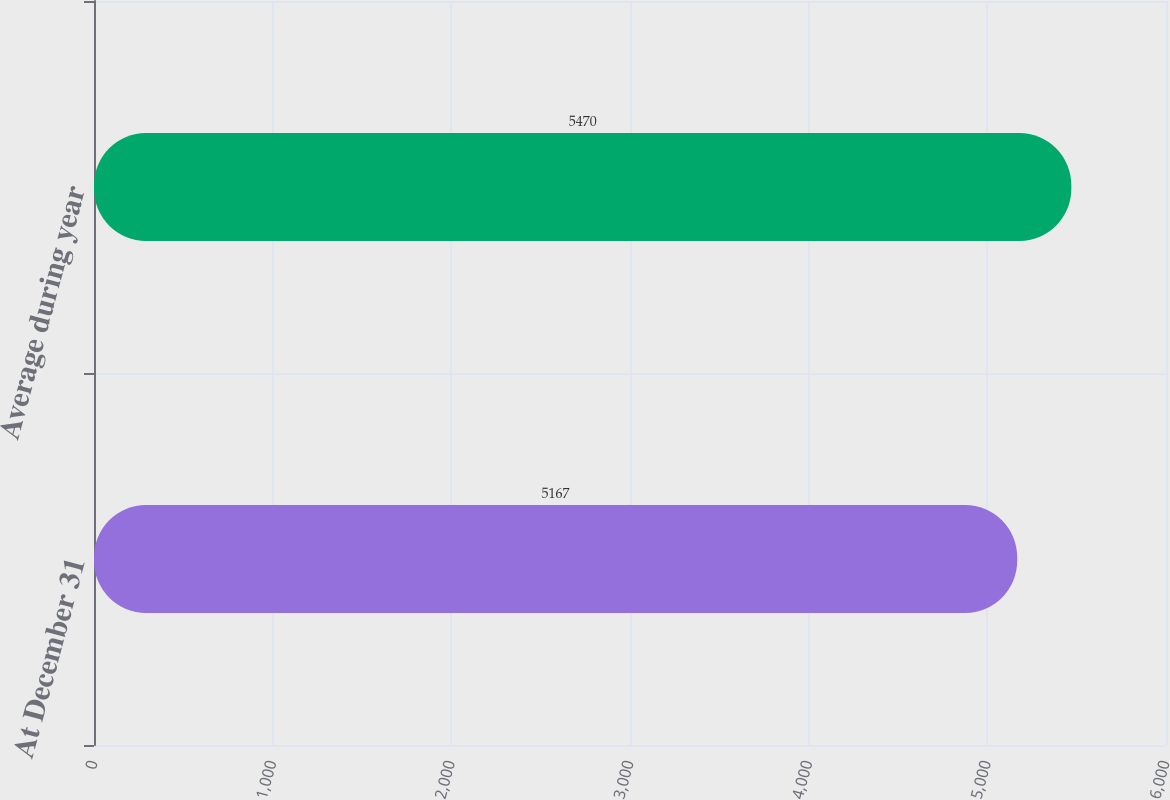<chart> <loc_0><loc_0><loc_500><loc_500><bar_chart><fcel>At December 31<fcel>Average during year<nl><fcel>5167<fcel>5470<nl></chart> 